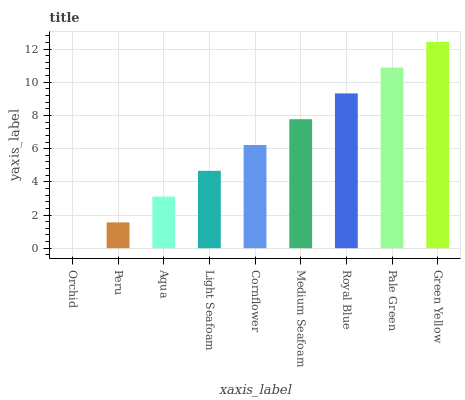Is Orchid the minimum?
Answer yes or no. Yes. Is Green Yellow the maximum?
Answer yes or no. Yes. Is Peru the minimum?
Answer yes or no. No. Is Peru the maximum?
Answer yes or no. No. Is Peru greater than Orchid?
Answer yes or no. Yes. Is Orchid less than Peru?
Answer yes or no. Yes. Is Orchid greater than Peru?
Answer yes or no. No. Is Peru less than Orchid?
Answer yes or no. No. Is Cornflower the high median?
Answer yes or no. Yes. Is Cornflower the low median?
Answer yes or no. Yes. Is Light Seafoam the high median?
Answer yes or no. No. Is Medium Seafoam the low median?
Answer yes or no. No. 